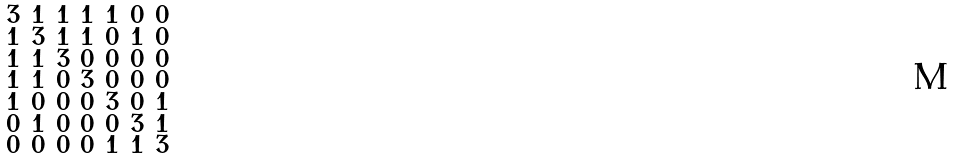<formula> <loc_0><loc_0><loc_500><loc_500>\begin{smallmatrix} 3 & 1 & 1 & 1 & 1 & 0 & 0 \\ 1 & 3 & 1 & 1 & 0 & 1 & 0 \\ 1 & 1 & 3 & 0 & 0 & 0 & 0 \\ 1 & 1 & 0 & 3 & 0 & 0 & 0 \\ 1 & 0 & 0 & 0 & 3 & 0 & 1 \\ 0 & 1 & 0 & 0 & 0 & 3 & 1 \\ 0 & 0 & 0 & 0 & 1 & 1 & 3 \end{smallmatrix}</formula> 